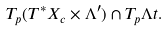<formula> <loc_0><loc_0><loc_500><loc_500>T _ { p } ( T ^ { * } X _ { c } \times \Lambda ^ { \prime } ) \cap T _ { p } \Lambda t .</formula> 